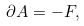Convert formula to latex. <formula><loc_0><loc_0><loc_500><loc_500>\partial A = - F ,</formula> 